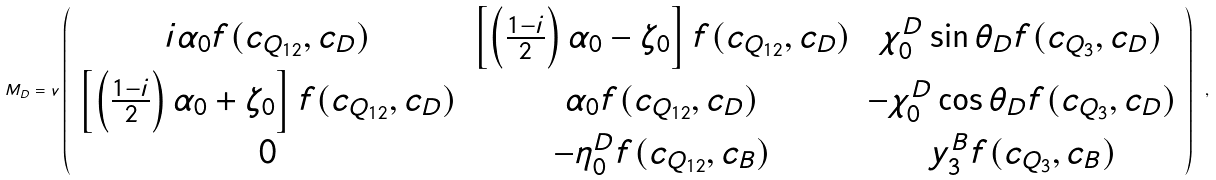Convert formula to latex. <formula><loc_0><loc_0><loc_500><loc_500>M _ { D } = v \left ( \begin{array} { c c c } i \alpha _ { 0 } f ( c _ { Q _ { 1 2 } } , c _ { D } ) & \left [ \left ( \frac { 1 - i } { 2 } \right ) \alpha _ { 0 } - \zeta _ { 0 } \right ] f ( c _ { Q _ { 1 2 } } , c _ { D } ) & \chi _ { 0 } ^ { D } \sin \theta _ { D } f ( c _ { Q _ { 3 } } , c _ { D } ) \\ \left [ \left ( \frac { 1 - i } { 2 } \right ) \alpha _ { 0 } + \zeta _ { 0 } \right ] f ( c _ { Q _ { 1 2 } } , c _ { D } ) & \alpha _ { 0 } f ( c _ { Q _ { 1 2 } } , c _ { D } ) & - \chi _ { 0 } ^ { D } \cos \theta _ { D } f ( c _ { Q _ { 3 } } , c _ { D } ) \\ 0 & - \eta _ { 0 } ^ { D } f ( c _ { Q _ { 1 2 } } , c _ { B } ) & y _ { 3 } ^ { B } f ( c _ { Q _ { 3 } } , c _ { B } ) \\ \end{array} \right ) \ ,</formula> 